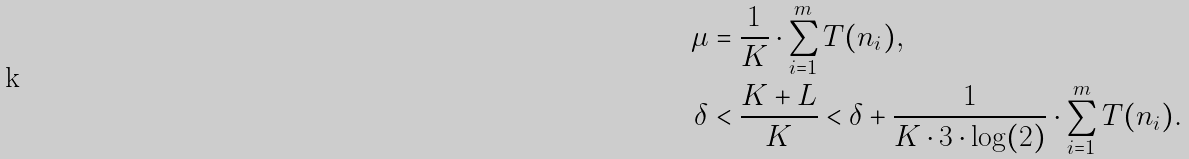Convert formula to latex. <formula><loc_0><loc_0><loc_500><loc_500>\mu & = \frac { 1 } { K } \cdot \sum _ { i = 1 } ^ { m } T ( n _ { i } ) , \\ \delta & < \frac { K + L } { K } < \delta + \frac { 1 } { K \cdot 3 \cdot \log ( 2 ) } \cdot \sum _ { i = 1 } ^ { m } T ( n _ { i } ) .</formula> 